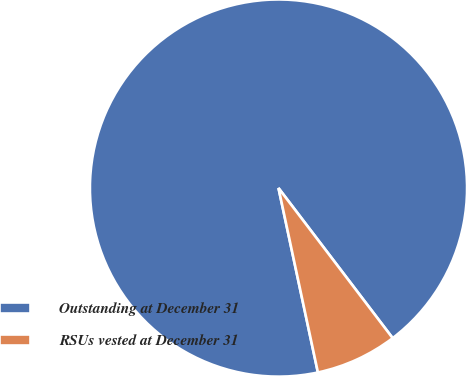<chart> <loc_0><loc_0><loc_500><loc_500><pie_chart><fcel>Outstanding at December 31<fcel>RSUs vested at December 31<nl><fcel>93.0%<fcel>7.0%<nl></chart> 